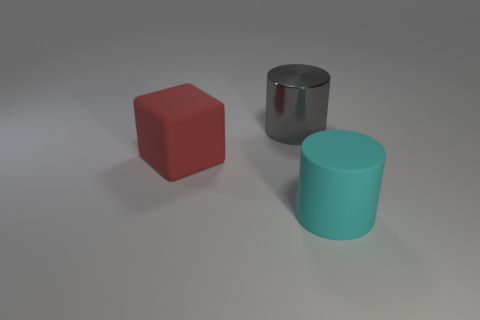Add 3 red objects. How many objects exist? 6 Subtract all cubes. How many objects are left? 2 Add 3 metal things. How many metal things are left? 4 Add 3 big rubber things. How many big rubber things exist? 5 Subtract 1 cyan cylinders. How many objects are left? 2 Subtract all shiny cylinders. Subtract all red objects. How many objects are left? 1 